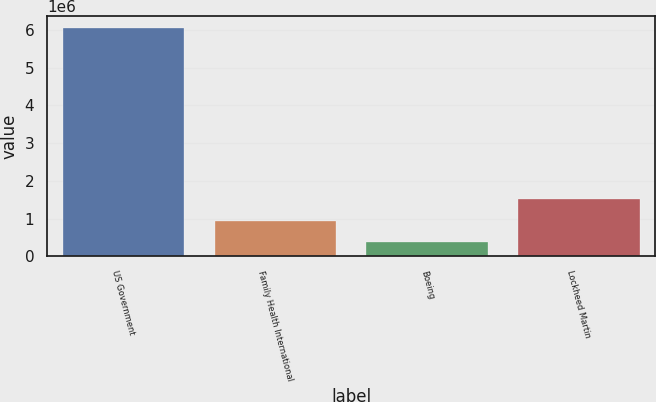Convert chart to OTSL. <chart><loc_0><loc_0><loc_500><loc_500><bar_chart><fcel>US Government<fcel>Family Health International<fcel>Boeing<fcel>Lockheed Martin<nl><fcel>6.054e+06<fcel>945600<fcel>378000<fcel>1.5132e+06<nl></chart> 